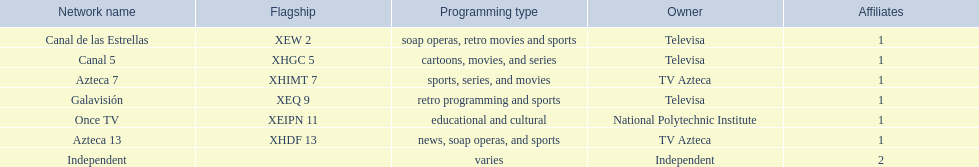Can you give me this table as a dict? {'header': ['Network name', 'Flagship', 'Programming type', 'Owner', 'Affiliates'], 'rows': [['Canal de las Estrellas', 'XEW 2', 'soap operas, retro movies and sports', 'Televisa', '1'], ['Canal 5', 'XHGC 5', 'cartoons, movies, and series', 'Televisa', '1'], ['Azteca 7', 'XHIMT 7', 'sports, series, and movies', 'TV Azteca', '1'], ['Galavisión', 'XEQ 9', 'retro programming and sports', 'Televisa', '1'], ['Once TV', 'XEIPN 11', 'educational and cultural', 'National Polytechnic Institute', '1'], ['Azteca 13', 'XHDF 13', 'news, soap operas, and sports', 'TV Azteca', '1'], ['Independent', '', 'varies', 'Independent', '2']]} What television channels can be found in morelos? Canal de las Estrellas, Canal 5, Azteca 7, Galavisión, Once TV, Azteca 13, Independent. Out of them, which is under the ownership of the national polytechnic institute? Once TV. 